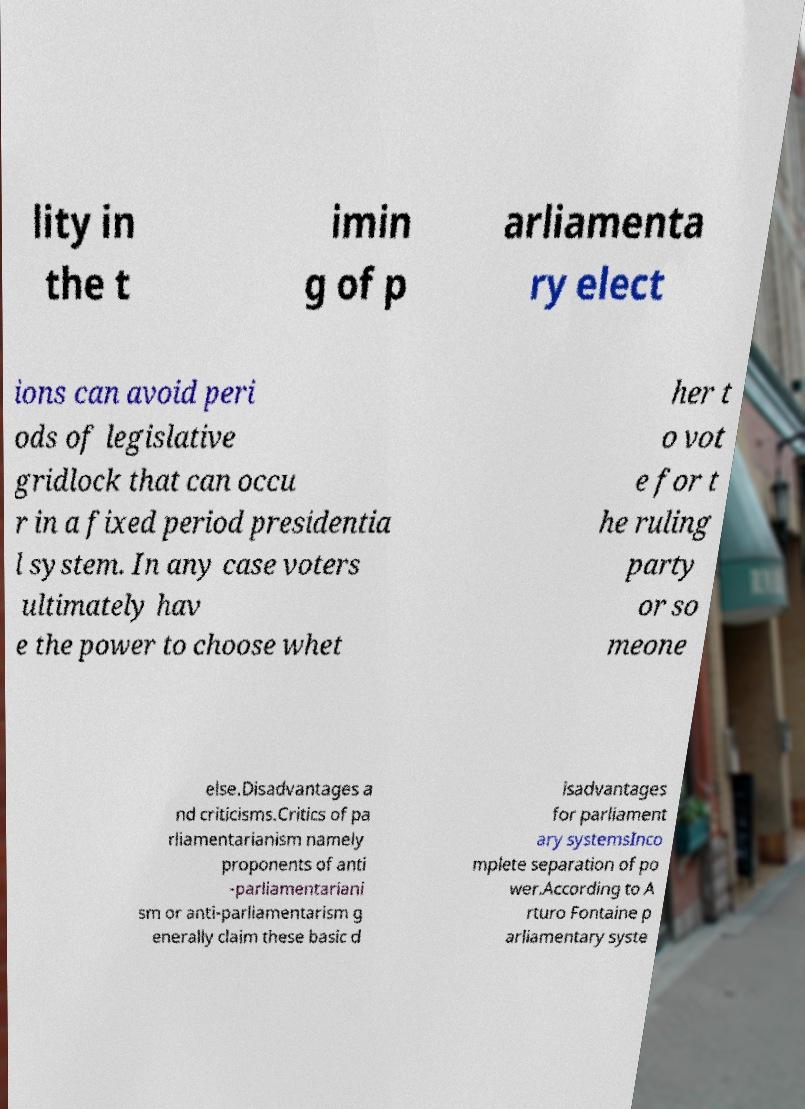Can you read and provide the text displayed in the image?This photo seems to have some interesting text. Can you extract and type it out for me? lity in the t imin g of p arliamenta ry elect ions can avoid peri ods of legislative gridlock that can occu r in a fixed period presidentia l system. In any case voters ultimately hav e the power to choose whet her t o vot e for t he ruling party or so meone else.Disadvantages a nd criticisms.Critics of pa rliamentarianism namely proponents of anti -parliamentariani sm or anti-parliamentarism g enerally claim these basic d isadvantages for parliament ary systemsInco mplete separation of po wer.According to A rturo Fontaine p arliamentary syste 